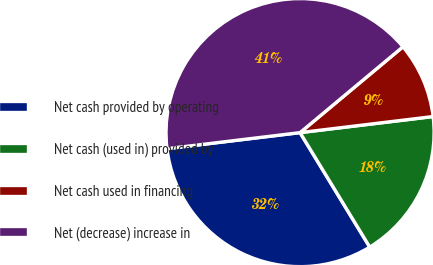Convert chart to OTSL. <chart><loc_0><loc_0><loc_500><loc_500><pie_chart><fcel>Net cash provided by operating<fcel>Net cash (used in) provided by<fcel>Net cash used in financing<fcel>Net (decrease) increase in<nl><fcel>31.79%<fcel>18.21%<fcel>9.15%<fcel>40.85%<nl></chart> 